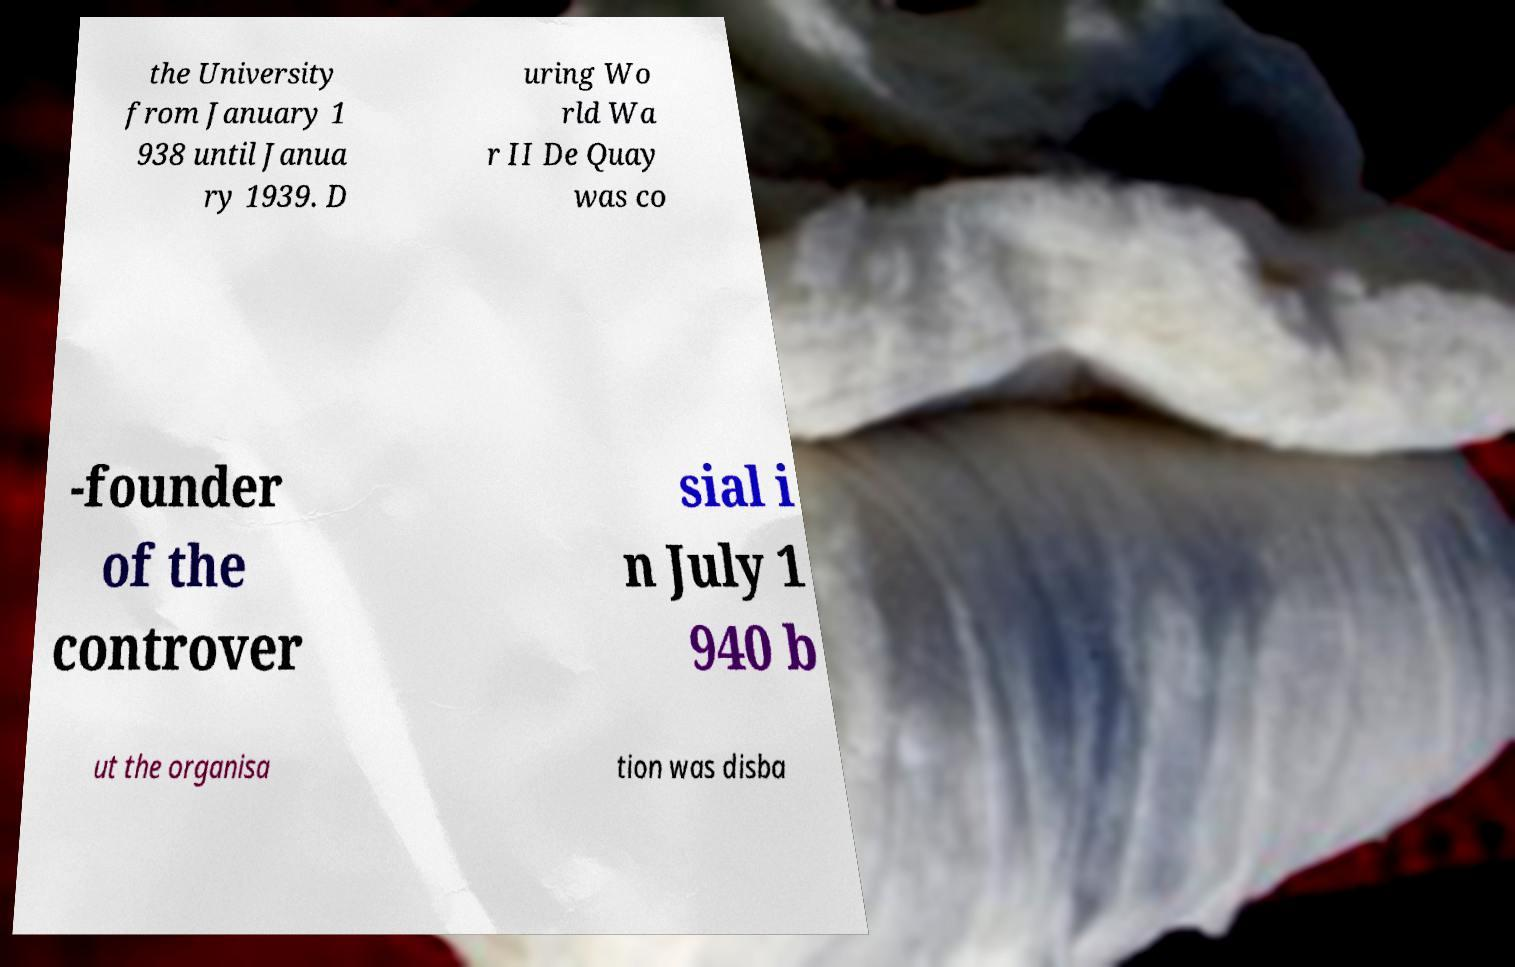Please read and relay the text visible in this image. What does it say? the University from January 1 938 until Janua ry 1939. D uring Wo rld Wa r II De Quay was co -founder of the controver sial i n July 1 940 b ut the organisa tion was disba 